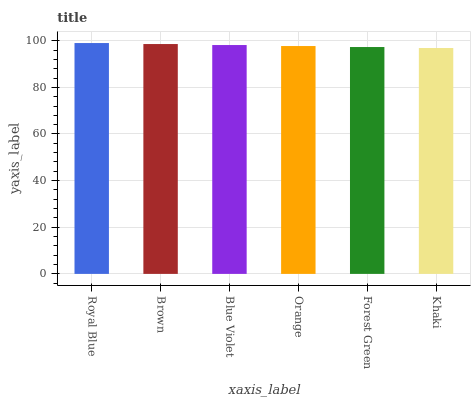Is Khaki the minimum?
Answer yes or no. Yes. Is Royal Blue the maximum?
Answer yes or no. Yes. Is Brown the minimum?
Answer yes or no. No. Is Brown the maximum?
Answer yes or no. No. Is Royal Blue greater than Brown?
Answer yes or no. Yes. Is Brown less than Royal Blue?
Answer yes or no. Yes. Is Brown greater than Royal Blue?
Answer yes or no. No. Is Royal Blue less than Brown?
Answer yes or no. No. Is Blue Violet the high median?
Answer yes or no. Yes. Is Orange the low median?
Answer yes or no. Yes. Is Khaki the high median?
Answer yes or no. No. Is Forest Green the low median?
Answer yes or no. No. 